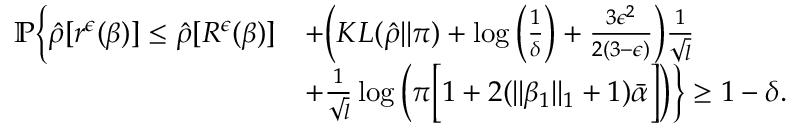<formula> <loc_0><loc_0><loc_500><loc_500>\begin{array} { r l } { \mathbb { P } \left \{ \hat { \rho } [ r ^ { \epsilon } ( \beta ) ] \leq \hat { \rho } [ R ^ { \epsilon } ( \beta ) ] } & { + \left ( K L ( \hat { \rho } | | \pi ) + \log \left ( \frac { 1 } { \delta } \right ) + \frac { 3 \epsilon ^ { 2 } } { 2 ( 3 - \epsilon ) } \right ) \frac { 1 } { \sqrt { l } } } \\ & { + \frac { 1 } { \sqrt { l } } \log \left ( \pi \left [ 1 + 2 ( \| \beta _ { 1 } \| _ { 1 } + 1 ) \bar { \alpha } \right ] \right ) \right \} \geq 1 - \delta . } \end{array}</formula> 